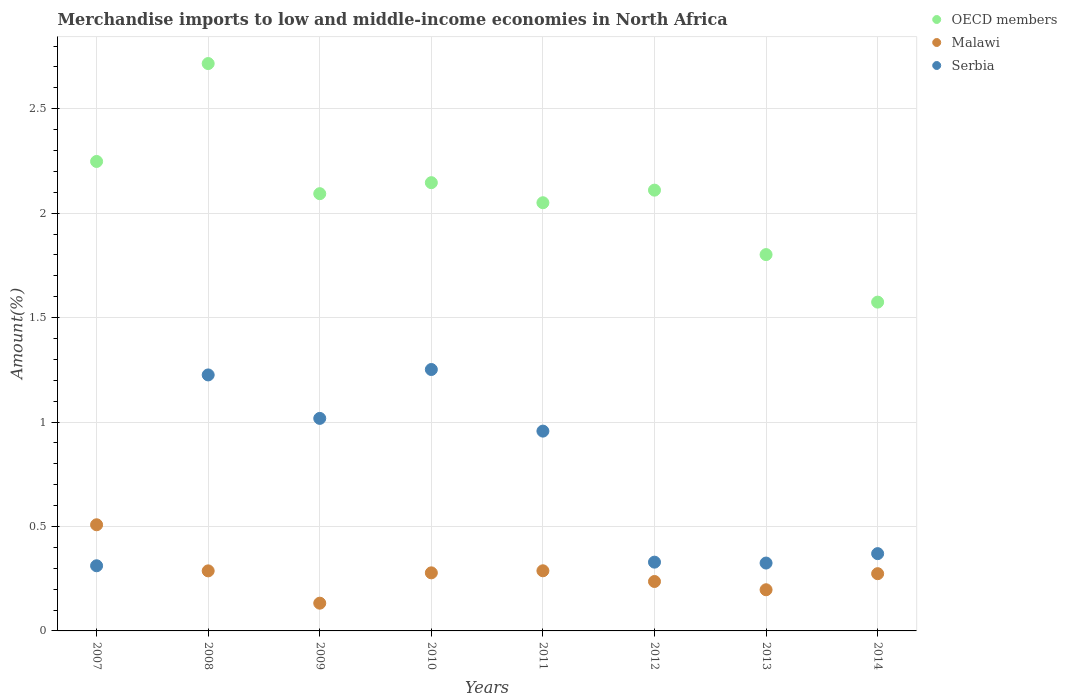How many different coloured dotlines are there?
Your response must be concise. 3. What is the percentage of amount earned from merchandise imports in Serbia in 2008?
Your response must be concise. 1.23. Across all years, what is the maximum percentage of amount earned from merchandise imports in Malawi?
Give a very brief answer. 0.51. Across all years, what is the minimum percentage of amount earned from merchandise imports in Malawi?
Provide a succinct answer. 0.13. What is the total percentage of amount earned from merchandise imports in Malawi in the graph?
Give a very brief answer. 2.2. What is the difference between the percentage of amount earned from merchandise imports in Malawi in 2011 and that in 2013?
Provide a succinct answer. 0.09. What is the difference between the percentage of amount earned from merchandise imports in OECD members in 2011 and the percentage of amount earned from merchandise imports in Malawi in 2007?
Provide a short and direct response. 1.54. What is the average percentage of amount earned from merchandise imports in Serbia per year?
Ensure brevity in your answer.  0.72. In the year 2012, what is the difference between the percentage of amount earned from merchandise imports in OECD members and percentage of amount earned from merchandise imports in Serbia?
Provide a succinct answer. 1.78. What is the ratio of the percentage of amount earned from merchandise imports in Malawi in 2009 to that in 2014?
Make the answer very short. 0.48. What is the difference between the highest and the second highest percentage of amount earned from merchandise imports in Malawi?
Give a very brief answer. 0.22. What is the difference between the highest and the lowest percentage of amount earned from merchandise imports in Malawi?
Give a very brief answer. 0.38. In how many years, is the percentage of amount earned from merchandise imports in Malawi greater than the average percentage of amount earned from merchandise imports in Malawi taken over all years?
Provide a short and direct response. 4. Does the percentage of amount earned from merchandise imports in OECD members monotonically increase over the years?
Ensure brevity in your answer.  No. How many dotlines are there?
Keep it short and to the point. 3. How many years are there in the graph?
Offer a very short reply. 8. What is the difference between two consecutive major ticks on the Y-axis?
Keep it short and to the point. 0.5. Are the values on the major ticks of Y-axis written in scientific E-notation?
Offer a very short reply. No. Does the graph contain any zero values?
Provide a short and direct response. No. Does the graph contain grids?
Provide a short and direct response. Yes. Where does the legend appear in the graph?
Provide a short and direct response. Top right. How many legend labels are there?
Your response must be concise. 3. What is the title of the graph?
Provide a succinct answer. Merchandise imports to low and middle-income economies in North Africa. Does "St. Martin (French part)" appear as one of the legend labels in the graph?
Keep it short and to the point. No. What is the label or title of the X-axis?
Provide a succinct answer. Years. What is the label or title of the Y-axis?
Your answer should be compact. Amount(%). What is the Amount(%) in OECD members in 2007?
Offer a very short reply. 2.25. What is the Amount(%) in Malawi in 2007?
Provide a short and direct response. 0.51. What is the Amount(%) in Serbia in 2007?
Your response must be concise. 0.31. What is the Amount(%) of OECD members in 2008?
Provide a short and direct response. 2.72. What is the Amount(%) in Malawi in 2008?
Your answer should be compact. 0.29. What is the Amount(%) of Serbia in 2008?
Your answer should be compact. 1.23. What is the Amount(%) of OECD members in 2009?
Your answer should be very brief. 2.09. What is the Amount(%) in Malawi in 2009?
Offer a terse response. 0.13. What is the Amount(%) of Serbia in 2009?
Your answer should be compact. 1.02. What is the Amount(%) in OECD members in 2010?
Your answer should be very brief. 2.15. What is the Amount(%) in Malawi in 2010?
Provide a succinct answer. 0.28. What is the Amount(%) of Serbia in 2010?
Provide a short and direct response. 1.25. What is the Amount(%) of OECD members in 2011?
Your answer should be compact. 2.05. What is the Amount(%) in Malawi in 2011?
Your answer should be compact. 0.29. What is the Amount(%) of Serbia in 2011?
Offer a very short reply. 0.96. What is the Amount(%) of OECD members in 2012?
Make the answer very short. 2.11. What is the Amount(%) in Malawi in 2012?
Keep it short and to the point. 0.24. What is the Amount(%) in Serbia in 2012?
Make the answer very short. 0.33. What is the Amount(%) of OECD members in 2013?
Make the answer very short. 1.8. What is the Amount(%) in Malawi in 2013?
Make the answer very short. 0.2. What is the Amount(%) of Serbia in 2013?
Your answer should be very brief. 0.32. What is the Amount(%) of OECD members in 2014?
Your answer should be very brief. 1.57. What is the Amount(%) in Malawi in 2014?
Offer a terse response. 0.27. What is the Amount(%) of Serbia in 2014?
Provide a succinct answer. 0.37. Across all years, what is the maximum Amount(%) in OECD members?
Your answer should be very brief. 2.72. Across all years, what is the maximum Amount(%) in Malawi?
Your response must be concise. 0.51. Across all years, what is the maximum Amount(%) in Serbia?
Your response must be concise. 1.25. Across all years, what is the minimum Amount(%) of OECD members?
Make the answer very short. 1.57. Across all years, what is the minimum Amount(%) of Malawi?
Your answer should be compact. 0.13. Across all years, what is the minimum Amount(%) in Serbia?
Make the answer very short. 0.31. What is the total Amount(%) in OECD members in the graph?
Give a very brief answer. 16.74. What is the total Amount(%) in Malawi in the graph?
Keep it short and to the point. 2.2. What is the total Amount(%) of Serbia in the graph?
Provide a succinct answer. 5.79. What is the difference between the Amount(%) of OECD members in 2007 and that in 2008?
Offer a very short reply. -0.47. What is the difference between the Amount(%) of Malawi in 2007 and that in 2008?
Offer a very short reply. 0.22. What is the difference between the Amount(%) of Serbia in 2007 and that in 2008?
Your answer should be compact. -0.91. What is the difference between the Amount(%) of OECD members in 2007 and that in 2009?
Your answer should be compact. 0.15. What is the difference between the Amount(%) of Malawi in 2007 and that in 2009?
Your answer should be very brief. 0.38. What is the difference between the Amount(%) of Serbia in 2007 and that in 2009?
Provide a short and direct response. -0.71. What is the difference between the Amount(%) of OECD members in 2007 and that in 2010?
Ensure brevity in your answer.  0.1. What is the difference between the Amount(%) in Malawi in 2007 and that in 2010?
Provide a short and direct response. 0.23. What is the difference between the Amount(%) in Serbia in 2007 and that in 2010?
Offer a terse response. -0.94. What is the difference between the Amount(%) in OECD members in 2007 and that in 2011?
Your response must be concise. 0.2. What is the difference between the Amount(%) of Malawi in 2007 and that in 2011?
Your answer should be compact. 0.22. What is the difference between the Amount(%) of Serbia in 2007 and that in 2011?
Make the answer very short. -0.64. What is the difference between the Amount(%) of OECD members in 2007 and that in 2012?
Your response must be concise. 0.14. What is the difference between the Amount(%) in Malawi in 2007 and that in 2012?
Offer a very short reply. 0.27. What is the difference between the Amount(%) in Serbia in 2007 and that in 2012?
Offer a very short reply. -0.02. What is the difference between the Amount(%) of OECD members in 2007 and that in 2013?
Ensure brevity in your answer.  0.45. What is the difference between the Amount(%) in Malawi in 2007 and that in 2013?
Ensure brevity in your answer.  0.31. What is the difference between the Amount(%) of Serbia in 2007 and that in 2013?
Offer a terse response. -0.01. What is the difference between the Amount(%) in OECD members in 2007 and that in 2014?
Keep it short and to the point. 0.67. What is the difference between the Amount(%) of Malawi in 2007 and that in 2014?
Ensure brevity in your answer.  0.23. What is the difference between the Amount(%) in Serbia in 2007 and that in 2014?
Your answer should be very brief. -0.06. What is the difference between the Amount(%) of OECD members in 2008 and that in 2009?
Provide a succinct answer. 0.62. What is the difference between the Amount(%) of Malawi in 2008 and that in 2009?
Offer a very short reply. 0.15. What is the difference between the Amount(%) in Serbia in 2008 and that in 2009?
Ensure brevity in your answer.  0.21. What is the difference between the Amount(%) in OECD members in 2008 and that in 2010?
Keep it short and to the point. 0.57. What is the difference between the Amount(%) in Malawi in 2008 and that in 2010?
Keep it short and to the point. 0.01. What is the difference between the Amount(%) of Serbia in 2008 and that in 2010?
Provide a short and direct response. -0.03. What is the difference between the Amount(%) of OECD members in 2008 and that in 2011?
Your answer should be very brief. 0.67. What is the difference between the Amount(%) of Malawi in 2008 and that in 2011?
Provide a succinct answer. -0. What is the difference between the Amount(%) in Serbia in 2008 and that in 2011?
Your response must be concise. 0.27. What is the difference between the Amount(%) of OECD members in 2008 and that in 2012?
Keep it short and to the point. 0.61. What is the difference between the Amount(%) in Malawi in 2008 and that in 2012?
Make the answer very short. 0.05. What is the difference between the Amount(%) of Serbia in 2008 and that in 2012?
Offer a terse response. 0.9. What is the difference between the Amount(%) of OECD members in 2008 and that in 2013?
Your answer should be compact. 0.91. What is the difference between the Amount(%) of Malawi in 2008 and that in 2013?
Ensure brevity in your answer.  0.09. What is the difference between the Amount(%) of Serbia in 2008 and that in 2013?
Give a very brief answer. 0.9. What is the difference between the Amount(%) of OECD members in 2008 and that in 2014?
Ensure brevity in your answer.  1.14. What is the difference between the Amount(%) in Malawi in 2008 and that in 2014?
Ensure brevity in your answer.  0.01. What is the difference between the Amount(%) of Serbia in 2008 and that in 2014?
Give a very brief answer. 0.86. What is the difference between the Amount(%) in OECD members in 2009 and that in 2010?
Your response must be concise. -0.05. What is the difference between the Amount(%) of Malawi in 2009 and that in 2010?
Your answer should be very brief. -0.15. What is the difference between the Amount(%) of Serbia in 2009 and that in 2010?
Provide a short and direct response. -0.23. What is the difference between the Amount(%) of OECD members in 2009 and that in 2011?
Make the answer very short. 0.04. What is the difference between the Amount(%) in Malawi in 2009 and that in 2011?
Give a very brief answer. -0.16. What is the difference between the Amount(%) in Serbia in 2009 and that in 2011?
Offer a very short reply. 0.06. What is the difference between the Amount(%) of OECD members in 2009 and that in 2012?
Provide a succinct answer. -0.02. What is the difference between the Amount(%) of Malawi in 2009 and that in 2012?
Ensure brevity in your answer.  -0.1. What is the difference between the Amount(%) of Serbia in 2009 and that in 2012?
Your answer should be compact. 0.69. What is the difference between the Amount(%) of OECD members in 2009 and that in 2013?
Offer a terse response. 0.29. What is the difference between the Amount(%) of Malawi in 2009 and that in 2013?
Ensure brevity in your answer.  -0.06. What is the difference between the Amount(%) of Serbia in 2009 and that in 2013?
Provide a succinct answer. 0.69. What is the difference between the Amount(%) of OECD members in 2009 and that in 2014?
Ensure brevity in your answer.  0.52. What is the difference between the Amount(%) of Malawi in 2009 and that in 2014?
Make the answer very short. -0.14. What is the difference between the Amount(%) of Serbia in 2009 and that in 2014?
Keep it short and to the point. 0.65. What is the difference between the Amount(%) in OECD members in 2010 and that in 2011?
Provide a short and direct response. 0.1. What is the difference between the Amount(%) in Malawi in 2010 and that in 2011?
Provide a succinct answer. -0.01. What is the difference between the Amount(%) in Serbia in 2010 and that in 2011?
Offer a terse response. 0.29. What is the difference between the Amount(%) of OECD members in 2010 and that in 2012?
Make the answer very short. 0.04. What is the difference between the Amount(%) in Malawi in 2010 and that in 2012?
Provide a succinct answer. 0.04. What is the difference between the Amount(%) in Serbia in 2010 and that in 2012?
Offer a very short reply. 0.92. What is the difference between the Amount(%) in OECD members in 2010 and that in 2013?
Provide a succinct answer. 0.34. What is the difference between the Amount(%) in Malawi in 2010 and that in 2013?
Keep it short and to the point. 0.08. What is the difference between the Amount(%) in Serbia in 2010 and that in 2013?
Your answer should be compact. 0.93. What is the difference between the Amount(%) of OECD members in 2010 and that in 2014?
Keep it short and to the point. 0.57. What is the difference between the Amount(%) in Malawi in 2010 and that in 2014?
Keep it short and to the point. 0. What is the difference between the Amount(%) of Serbia in 2010 and that in 2014?
Your response must be concise. 0.88. What is the difference between the Amount(%) in OECD members in 2011 and that in 2012?
Your response must be concise. -0.06. What is the difference between the Amount(%) in Malawi in 2011 and that in 2012?
Your answer should be compact. 0.05. What is the difference between the Amount(%) of Serbia in 2011 and that in 2012?
Ensure brevity in your answer.  0.63. What is the difference between the Amount(%) in OECD members in 2011 and that in 2013?
Offer a very short reply. 0.25. What is the difference between the Amount(%) of Malawi in 2011 and that in 2013?
Your answer should be compact. 0.09. What is the difference between the Amount(%) in Serbia in 2011 and that in 2013?
Offer a terse response. 0.63. What is the difference between the Amount(%) of OECD members in 2011 and that in 2014?
Provide a succinct answer. 0.48. What is the difference between the Amount(%) in Malawi in 2011 and that in 2014?
Keep it short and to the point. 0.01. What is the difference between the Amount(%) of Serbia in 2011 and that in 2014?
Offer a very short reply. 0.59. What is the difference between the Amount(%) in OECD members in 2012 and that in 2013?
Provide a succinct answer. 0.31. What is the difference between the Amount(%) in Malawi in 2012 and that in 2013?
Offer a very short reply. 0.04. What is the difference between the Amount(%) of Serbia in 2012 and that in 2013?
Your answer should be very brief. 0. What is the difference between the Amount(%) in OECD members in 2012 and that in 2014?
Provide a short and direct response. 0.54. What is the difference between the Amount(%) of Malawi in 2012 and that in 2014?
Your response must be concise. -0.04. What is the difference between the Amount(%) in Serbia in 2012 and that in 2014?
Give a very brief answer. -0.04. What is the difference between the Amount(%) in OECD members in 2013 and that in 2014?
Give a very brief answer. 0.23. What is the difference between the Amount(%) of Malawi in 2013 and that in 2014?
Your response must be concise. -0.08. What is the difference between the Amount(%) of Serbia in 2013 and that in 2014?
Provide a succinct answer. -0.05. What is the difference between the Amount(%) in OECD members in 2007 and the Amount(%) in Malawi in 2008?
Keep it short and to the point. 1.96. What is the difference between the Amount(%) of OECD members in 2007 and the Amount(%) of Serbia in 2008?
Provide a succinct answer. 1.02. What is the difference between the Amount(%) in Malawi in 2007 and the Amount(%) in Serbia in 2008?
Keep it short and to the point. -0.72. What is the difference between the Amount(%) of OECD members in 2007 and the Amount(%) of Malawi in 2009?
Your response must be concise. 2.11. What is the difference between the Amount(%) in OECD members in 2007 and the Amount(%) in Serbia in 2009?
Ensure brevity in your answer.  1.23. What is the difference between the Amount(%) of Malawi in 2007 and the Amount(%) of Serbia in 2009?
Give a very brief answer. -0.51. What is the difference between the Amount(%) in OECD members in 2007 and the Amount(%) in Malawi in 2010?
Offer a terse response. 1.97. What is the difference between the Amount(%) of Malawi in 2007 and the Amount(%) of Serbia in 2010?
Ensure brevity in your answer.  -0.74. What is the difference between the Amount(%) in OECD members in 2007 and the Amount(%) in Malawi in 2011?
Provide a succinct answer. 1.96. What is the difference between the Amount(%) in OECD members in 2007 and the Amount(%) in Serbia in 2011?
Provide a succinct answer. 1.29. What is the difference between the Amount(%) in Malawi in 2007 and the Amount(%) in Serbia in 2011?
Your answer should be compact. -0.45. What is the difference between the Amount(%) in OECD members in 2007 and the Amount(%) in Malawi in 2012?
Ensure brevity in your answer.  2.01. What is the difference between the Amount(%) of OECD members in 2007 and the Amount(%) of Serbia in 2012?
Provide a short and direct response. 1.92. What is the difference between the Amount(%) in Malawi in 2007 and the Amount(%) in Serbia in 2012?
Give a very brief answer. 0.18. What is the difference between the Amount(%) of OECD members in 2007 and the Amount(%) of Malawi in 2013?
Your answer should be very brief. 2.05. What is the difference between the Amount(%) of OECD members in 2007 and the Amount(%) of Serbia in 2013?
Offer a terse response. 1.92. What is the difference between the Amount(%) in Malawi in 2007 and the Amount(%) in Serbia in 2013?
Keep it short and to the point. 0.18. What is the difference between the Amount(%) in OECD members in 2007 and the Amount(%) in Malawi in 2014?
Offer a very short reply. 1.97. What is the difference between the Amount(%) of OECD members in 2007 and the Amount(%) of Serbia in 2014?
Your response must be concise. 1.88. What is the difference between the Amount(%) of Malawi in 2007 and the Amount(%) of Serbia in 2014?
Give a very brief answer. 0.14. What is the difference between the Amount(%) in OECD members in 2008 and the Amount(%) in Malawi in 2009?
Keep it short and to the point. 2.58. What is the difference between the Amount(%) in OECD members in 2008 and the Amount(%) in Serbia in 2009?
Ensure brevity in your answer.  1.7. What is the difference between the Amount(%) in Malawi in 2008 and the Amount(%) in Serbia in 2009?
Your response must be concise. -0.73. What is the difference between the Amount(%) in OECD members in 2008 and the Amount(%) in Malawi in 2010?
Ensure brevity in your answer.  2.44. What is the difference between the Amount(%) in OECD members in 2008 and the Amount(%) in Serbia in 2010?
Give a very brief answer. 1.46. What is the difference between the Amount(%) of Malawi in 2008 and the Amount(%) of Serbia in 2010?
Your response must be concise. -0.96. What is the difference between the Amount(%) in OECD members in 2008 and the Amount(%) in Malawi in 2011?
Provide a short and direct response. 2.43. What is the difference between the Amount(%) of OECD members in 2008 and the Amount(%) of Serbia in 2011?
Provide a short and direct response. 1.76. What is the difference between the Amount(%) of Malawi in 2008 and the Amount(%) of Serbia in 2011?
Offer a terse response. -0.67. What is the difference between the Amount(%) in OECD members in 2008 and the Amount(%) in Malawi in 2012?
Your response must be concise. 2.48. What is the difference between the Amount(%) in OECD members in 2008 and the Amount(%) in Serbia in 2012?
Make the answer very short. 2.39. What is the difference between the Amount(%) in Malawi in 2008 and the Amount(%) in Serbia in 2012?
Make the answer very short. -0.04. What is the difference between the Amount(%) of OECD members in 2008 and the Amount(%) of Malawi in 2013?
Ensure brevity in your answer.  2.52. What is the difference between the Amount(%) in OECD members in 2008 and the Amount(%) in Serbia in 2013?
Ensure brevity in your answer.  2.39. What is the difference between the Amount(%) in Malawi in 2008 and the Amount(%) in Serbia in 2013?
Make the answer very short. -0.04. What is the difference between the Amount(%) of OECD members in 2008 and the Amount(%) of Malawi in 2014?
Ensure brevity in your answer.  2.44. What is the difference between the Amount(%) in OECD members in 2008 and the Amount(%) in Serbia in 2014?
Make the answer very short. 2.35. What is the difference between the Amount(%) of Malawi in 2008 and the Amount(%) of Serbia in 2014?
Your answer should be very brief. -0.08. What is the difference between the Amount(%) of OECD members in 2009 and the Amount(%) of Malawi in 2010?
Your response must be concise. 1.82. What is the difference between the Amount(%) of OECD members in 2009 and the Amount(%) of Serbia in 2010?
Your answer should be very brief. 0.84. What is the difference between the Amount(%) of Malawi in 2009 and the Amount(%) of Serbia in 2010?
Offer a terse response. -1.12. What is the difference between the Amount(%) in OECD members in 2009 and the Amount(%) in Malawi in 2011?
Provide a short and direct response. 1.81. What is the difference between the Amount(%) of OECD members in 2009 and the Amount(%) of Serbia in 2011?
Your answer should be compact. 1.14. What is the difference between the Amount(%) of Malawi in 2009 and the Amount(%) of Serbia in 2011?
Make the answer very short. -0.82. What is the difference between the Amount(%) in OECD members in 2009 and the Amount(%) in Malawi in 2012?
Your response must be concise. 1.86. What is the difference between the Amount(%) of OECD members in 2009 and the Amount(%) of Serbia in 2012?
Provide a short and direct response. 1.76. What is the difference between the Amount(%) of Malawi in 2009 and the Amount(%) of Serbia in 2012?
Your answer should be very brief. -0.2. What is the difference between the Amount(%) in OECD members in 2009 and the Amount(%) in Malawi in 2013?
Give a very brief answer. 1.9. What is the difference between the Amount(%) in OECD members in 2009 and the Amount(%) in Serbia in 2013?
Make the answer very short. 1.77. What is the difference between the Amount(%) of Malawi in 2009 and the Amount(%) of Serbia in 2013?
Ensure brevity in your answer.  -0.19. What is the difference between the Amount(%) in OECD members in 2009 and the Amount(%) in Malawi in 2014?
Your answer should be compact. 1.82. What is the difference between the Amount(%) in OECD members in 2009 and the Amount(%) in Serbia in 2014?
Make the answer very short. 1.72. What is the difference between the Amount(%) of Malawi in 2009 and the Amount(%) of Serbia in 2014?
Give a very brief answer. -0.24. What is the difference between the Amount(%) of OECD members in 2010 and the Amount(%) of Malawi in 2011?
Offer a very short reply. 1.86. What is the difference between the Amount(%) in OECD members in 2010 and the Amount(%) in Serbia in 2011?
Offer a very short reply. 1.19. What is the difference between the Amount(%) in Malawi in 2010 and the Amount(%) in Serbia in 2011?
Offer a very short reply. -0.68. What is the difference between the Amount(%) in OECD members in 2010 and the Amount(%) in Malawi in 2012?
Provide a short and direct response. 1.91. What is the difference between the Amount(%) in OECD members in 2010 and the Amount(%) in Serbia in 2012?
Offer a very short reply. 1.82. What is the difference between the Amount(%) of Malawi in 2010 and the Amount(%) of Serbia in 2012?
Your answer should be very brief. -0.05. What is the difference between the Amount(%) of OECD members in 2010 and the Amount(%) of Malawi in 2013?
Ensure brevity in your answer.  1.95. What is the difference between the Amount(%) in OECD members in 2010 and the Amount(%) in Serbia in 2013?
Offer a very short reply. 1.82. What is the difference between the Amount(%) of Malawi in 2010 and the Amount(%) of Serbia in 2013?
Ensure brevity in your answer.  -0.05. What is the difference between the Amount(%) in OECD members in 2010 and the Amount(%) in Malawi in 2014?
Your answer should be compact. 1.87. What is the difference between the Amount(%) in OECD members in 2010 and the Amount(%) in Serbia in 2014?
Give a very brief answer. 1.78. What is the difference between the Amount(%) of Malawi in 2010 and the Amount(%) of Serbia in 2014?
Ensure brevity in your answer.  -0.09. What is the difference between the Amount(%) in OECD members in 2011 and the Amount(%) in Malawi in 2012?
Your response must be concise. 1.81. What is the difference between the Amount(%) of OECD members in 2011 and the Amount(%) of Serbia in 2012?
Offer a terse response. 1.72. What is the difference between the Amount(%) in Malawi in 2011 and the Amount(%) in Serbia in 2012?
Make the answer very short. -0.04. What is the difference between the Amount(%) in OECD members in 2011 and the Amount(%) in Malawi in 2013?
Your answer should be compact. 1.85. What is the difference between the Amount(%) in OECD members in 2011 and the Amount(%) in Serbia in 2013?
Offer a terse response. 1.73. What is the difference between the Amount(%) of Malawi in 2011 and the Amount(%) of Serbia in 2013?
Ensure brevity in your answer.  -0.04. What is the difference between the Amount(%) in OECD members in 2011 and the Amount(%) in Malawi in 2014?
Offer a terse response. 1.78. What is the difference between the Amount(%) of OECD members in 2011 and the Amount(%) of Serbia in 2014?
Your answer should be very brief. 1.68. What is the difference between the Amount(%) in Malawi in 2011 and the Amount(%) in Serbia in 2014?
Your answer should be very brief. -0.08. What is the difference between the Amount(%) in OECD members in 2012 and the Amount(%) in Malawi in 2013?
Provide a short and direct response. 1.91. What is the difference between the Amount(%) in OECD members in 2012 and the Amount(%) in Serbia in 2013?
Ensure brevity in your answer.  1.79. What is the difference between the Amount(%) in Malawi in 2012 and the Amount(%) in Serbia in 2013?
Your answer should be compact. -0.09. What is the difference between the Amount(%) in OECD members in 2012 and the Amount(%) in Malawi in 2014?
Your answer should be compact. 1.84. What is the difference between the Amount(%) of OECD members in 2012 and the Amount(%) of Serbia in 2014?
Give a very brief answer. 1.74. What is the difference between the Amount(%) of Malawi in 2012 and the Amount(%) of Serbia in 2014?
Give a very brief answer. -0.13. What is the difference between the Amount(%) of OECD members in 2013 and the Amount(%) of Malawi in 2014?
Ensure brevity in your answer.  1.53. What is the difference between the Amount(%) of OECD members in 2013 and the Amount(%) of Serbia in 2014?
Offer a very short reply. 1.43. What is the difference between the Amount(%) of Malawi in 2013 and the Amount(%) of Serbia in 2014?
Your answer should be very brief. -0.17. What is the average Amount(%) of OECD members per year?
Your answer should be very brief. 2.09. What is the average Amount(%) of Malawi per year?
Your answer should be compact. 0.28. What is the average Amount(%) in Serbia per year?
Keep it short and to the point. 0.72. In the year 2007, what is the difference between the Amount(%) of OECD members and Amount(%) of Malawi?
Your answer should be compact. 1.74. In the year 2007, what is the difference between the Amount(%) of OECD members and Amount(%) of Serbia?
Ensure brevity in your answer.  1.94. In the year 2007, what is the difference between the Amount(%) in Malawi and Amount(%) in Serbia?
Keep it short and to the point. 0.2. In the year 2008, what is the difference between the Amount(%) in OECD members and Amount(%) in Malawi?
Ensure brevity in your answer.  2.43. In the year 2008, what is the difference between the Amount(%) in OECD members and Amount(%) in Serbia?
Provide a short and direct response. 1.49. In the year 2008, what is the difference between the Amount(%) in Malawi and Amount(%) in Serbia?
Your answer should be compact. -0.94. In the year 2009, what is the difference between the Amount(%) in OECD members and Amount(%) in Malawi?
Give a very brief answer. 1.96. In the year 2009, what is the difference between the Amount(%) in OECD members and Amount(%) in Serbia?
Ensure brevity in your answer.  1.08. In the year 2009, what is the difference between the Amount(%) of Malawi and Amount(%) of Serbia?
Provide a succinct answer. -0.88. In the year 2010, what is the difference between the Amount(%) in OECD members and Amount(%) in Malawi?
Offer a very short reply. 1.87. In the year 2010, what is the difference between the Amount(%) of OECD members and Amount(%) of Serbia?
Provide a short and direct response. 0.89. In the year 2010, what is the difference between the Amount(%) of Malawi and Amount(%) of Serbia?
Your answer should be very brief. -0.97. In the year 2011, what is the difference between the Amount(%) of OECD members and Amount(%) of Malawi?
Provide a succinct answer. 1.76. In the year 2011, what is the difference between the Amount(%) in OECD members and Amount(%) in Serbia?
Offer a terse response. 1.09. In the year 2011, what is the difference between the Amount(%) in Malawi and Amount(%) in Serbia?
Ensure brevity in your answer.  -0.67. In the year 2012, what is the difference between the Amount(%) of OECD members and Amount(%) of Malawi?
Offer a terse response. 1.87. In the year 2012, what is the difference between the Amount(%) of OECD members and Amount(%) of Serbia?
Give a very brief answer. 1.78. In the year 2012, what is the difference between the Amount(%) in Malawi and Amount(%) in Serbia?
Offer a very short reply. -0.09. In the year 2013, what is the difference between the Amount(%) of OECD members and Amount(%) of Malawi?
Ensure brevity in your answer.  1.6. In the year 2013, what is the difference between the Amount(%) in OECD members and Amount(%) in Serbia?
Your response must be concise. 1.48. In the year 2013, what is the difference between the Amount(%) of Malawi and Amount(%) of Serbia?
Ensure brevity in your answer.  -0.13. In the year 2014, what is the difference between the Amount(%) of OECD members and Amount(%) of Malawi?
Make the answer very short. 1.3. In the year 2014, what is the difference between the Amount(%) in OECD members and Amount(%) in Serbia?
Keep it short and to the point. 1.2. In the year 2014, what is the difference between the Amount(%) in Malawi and Amount(%) in Serbia?
Offer a very short reply. -0.1. What is the ratio of the Amount(%) of OECD members in 2007 to that in 2008?
Provide a short and direct response. 0.83. What is the ratio of the Amount(%) of Malawi in 2007 to that in 2008?
Keep it short and to the point. 1.77. What is the ratio of the Amount(%) in Serbia in 2007 to that in 2008?
Offer a very short reply. 0.25. What is the ratio of the Amount(%) of OECD members in 2007 to that in 2009?
Provide a short and direct response. 1.07. What is the ratio of the Amount(%) of Malawi in 2007 to that in 2009?
Offer a very short reply. 3.83. What is the ratio of the Amount(%) in Serbia in 2007 to that in 2009?
Provide a short and direct response. 0.31. What is the ratio of the Amount(%) of OECD members in 2007 to that in 2010?
Make the answer very short. 1.05. What is the ratio of the Amount(%) of Malawi in 2007 to that in 2010?
Provide a succinct answer. 1.83. What is the ratio of the Amount(%) of Serbia in 2007 to that in 2010?
Your answer should be very brief. 0.25. What is the ratio of the Amount(%) of OECD members in 2007 to that in 2011?
Keep it short and to the point. 1.1. What is the ratio of the Amount(%) in Malawi in 2007 to that in 2011?
Ensure brevity in your answer.  1.77. What is the ratio of the Amount(%) in Serbia in 2007 to that in 2011?
Provide a short and direct response. 0.33. What is the ratio of the Amount(%) in OECD members in 2007 to that in 2012?
Keep it short and to the point. 1.07. What is the ratio of the Amount(%) of Malawi in 2007 to that in 2012?
Provide a succinct answer. 2.15. What is the ratio of the Amount(%) of Serbia in 2007 to that in 2012?
Offer a terse response. 0.95. What is the ratio of the Amount(%) of OECD members in 2007 to that in 2013?
Offer a very short reply. 1.25. What is the ratio of the Amount(%) of Malawi in 2007 to that in 2013?
Provide a short and direct response. 2.58. What is the ratio of the Amount(%) in Serbia in 2007 to that in 2013?
Offer a terse response. 0.96. What is the ratio of the Amount(%) of OECD members in 2007 to that in 2014?
Provide a short and direct response. 1.43. What is the ratio of the Amount(%) in Malawi in 2007 to that in 2014?
Your answer should be compact. 1.85. What is the ratio of the Amount(%) in Serbia in 2007 to that in 2014?
Offer a very short reply. 0.84. What is the ratio of the Amount(%) of OECD members in 2008 to that in 2009?
Your response must be concise. 1.3. What is the ratio of the Amount(%) of Malawi in 2008 to that in 2009?
Provide a succinct answer. 2.16. What is the ratio of the Amount(%) of Serbia in 2008 to that in 2009?
Your response must be concise. 1.2. What is the ratio of the Amount(%) in OECD members in 2008 to that in 2010?
Provide a succinct answer. 1.27. What is the ratio of the Amount(%) of Malawi in 2008 to that in 2010?
Provide a short and direct response. 1.03. What is the ratio of the Amount(%) in Serbia in 2008 to that in 2010?
Ensure brevity in your answer.  0.98. What is the ratio of the Amount(%) in OECD members in 2008 to that in 2011?
Offer a very short reply. 1.32. What is the ratio of the Amount(%) in Serbia in 2008 to that in 2011?
Provide a short and direct response. 1.28. What is the ratio of the Amount(%) in OECD members in 2008 to that in 2012?
Make the answer very short. 1.29. What is the ratio of the Amount(%) of Malawi in 2008 to that in 2012?
Make the answer very short. 1.21. What is the ratio of the Amount(%) of Serbia in 2008 to that in 2012?
Offer a very short reply. 3.72. What is the ratio of the Amount(%) in OECD members in 2008 to that in 2013?
Provide a short and direct response. 1.51. What is the ratio of the Amount(%) in Malawi in 2008 to that in 2013?
Your answer should be very brief. 1.46. What is the ratio of the Amount(%) in Serbia in 2008 to that in 2013?
Your answer should be compact. 3.77. What is the ratio of the Amount(%) of OECD members in 2008 to that in 2014?
Your answer should be very brief. 1.73. What is the ratio of the Amount(%) of Malawi in 2008 to that in 2014?
Your answer should be very brief. 1.05. What is the ratio of the Amount(%) of Serbia in 2008 to that in 2014?
Offer a terse response. 3.31. What is the ratio of the Amount(%) of OECD members in 2009 to that in 2010?
Make the answer very short. 0.98. What is the ratio of the Amount(%) of Malawi in 2009 to that in 2010?
Make the answer very short. 0.48. What is the ratio of the Amount(%) in Serbia in 2009 to that in 2010?
Offer a very short reply. 0.81. What is the ratio of the Amount(%) in OECD members in 2009 to that in 2011?
Your response must be concise. 1.02. What is the ratio of the Amount(%) of Malawi in 2009 to that in 2011?
Ensure brevity in your answer.  0.46. What is the ratio of the Amount(%) in Serbia in 2009 to that in 2011?
Make the answer very short. 1.06. What is the ratio of the Amount(%) of OECD members in 2009 to that in 2012?
Give a very brief answer. 0.99. What is the ratio of the Amount(%) of Malawi in 2009 to that in 2012?
Keep it short and to the point. 0.56. What is the ratio of the Amount(%) in Serbia in 2009 to that in 2012?
Your response must be concise. 3.09. What is the ratio of the Amount(%) of OECD members in 2009 to that in 2013?
Provide a short and direct response. 1.16. What is the ratio of the Amount(%) in Malawi in 2009 to that in 2013?
Your answer should be compact. 0.67. What is the ratio of the Amount(%) of Serbia in 2009 to that in 2013?
Ensure brevity in your answer.  3.13. What is the ratio of the Amount(%) in OECD members in 2009 to that in 2014?
Provide a succinct answer. 1.33. What is the ratio of the Amount(%) of Malawi in 2009 to that in 2014?
Offer a very short reply. 0.48. What is the ratio of the Amount(%) of Serbia in 2009 to that in 2014?
Your response must be concise. 2.75. What is the ratio of the Amount(%) of OECD members in 2010 to that in 2011?
Offer a very short reply. 1.05. What is the ratio of the Amount(%) in Malawi in 2010 to that in 2011?
Your answer should be compact. 0.97. What is the ratio of the Amount(%) of Serbia in 2010 to that in 2011?
Your answer should be compact. 1.31. What is the ratio of the Amount(%) of Malawi in 2010 to that in 2012?
Your answer should be very brief. 1.17. What is the ratio of the Amount(%) of Serbia in 2010 to that in 2012?
Your answer should be compact. 3.8. What is the ratio of the Amount(%) in OECD members in 2010 to that in 2013?
Give a very brief answer. 1.19. What is the ratio of the Amount(%) of Malawi in 2010 to that in 2013?
Provide a succinct answer. 1.41. What is the ratio of the Amount(%) in Serbia in 2010 to that in 2013?
Your response must be concise. 3.85. What is the ratio of the Amount(%) of OECD members in 2010 to that in 2014?
Your response must be concise. 1.36. What is the ratio of the Amount(%) in Malawi in 2010 to that in 2014?
Ensure brevity in your answer.  1.01. What is the ratio of the Amount(%) of Serbia in 2010 to that in 2014?
Give a very brief answer. 3.38. What is the ratio of the Amount(%) of OECD members in 2011 to that in 2012?
Make the answer very short. 0.97. What is the ratio of the Amount(%) of Malawi in 2011 to that in 2012?
Your answer should be compact. 1.22. What is the ratio of the Amount(%) of Serbia in 2011 to that in 2012?
Keep it short and to the point. 2.91. What is the ratio of the Amount(%) of OECD members in 2011 to that in 2013?
Provide a short and direct response. 1.14. What is the ratio of the Amount(%) in Malawi in 2011 to that in 2013?
Offer a terse response. 1.46. What is the ratio of the Amount(%) in Serbia in 2011 to that in 2013?
Provide a succinct answer. 2.94. What is the ratio of the Amount(%) of OECD members in 2011 to that in 2014?
Your answer should be very brief. 1.3. What is the ratio of the Amount(%) of Malawi in 2011 to that in 2014?
Offer a very short reply. 1.05. What is the ratio of the Amount(%) in Serbia in 2011 to that in 2014?
Your answer should be very brief. 2.59. What is the ratio of the Amount(%) in OECD members in 2012 to that in 2013?
Your response must be concise. 1.17. What is the ratio of the Amount(%) in Malawi in 2012 to that in 2013?
Offer a very short reply. 1.2. What is the ratio of the Amount(%) in Serbia in 2012 to that in 2013?
Give a very brief answer. 1.01. What is the ratio of the Amount(%) in OECD members in 2012 to that in 2014?
Your response must be concise. 1.34. What is the ratio of the Amount(%) in Malawi in 2012 to that in 2014?
Your answer should be very brief. 0.86. What is the ratio of the Amount(%) of Serbia in 2012 to that in 2014?
Your response must be concise. 0.89. What is the ratio of the Amount(%) of OECD members in 2013 to that in 2014?
Give a very brief answer. 1.14. What is the ratio of the Amount(%) in Malawi in 2013 to that in 2014?
Provide a succinct answer. 0.72. What is the ratio of the Amount(%) in Serbia in 2013 to that in 2014?
Make the answer very short. 0.88. What is the difference between the highest and the second highest Amount(%) in OECD members?
Keep it short and to the point. 0.47. What is the difference between the highest and the second highest Amount(%) in Malawi?
Offer a terse response. 0.22. What is the difference between the highest and the second highest Amount(%) in Serbia?
Your answer should be very brief. 0.03. What is the difference between the highest and the lowest Amount(%) in OECD members?
Your answer should be very brief. 1.14. What is the difference between the highest and the lowest Amount(%) of Malawi?
Give a very brief answer. 0.38. What is the difference between the highest and the lowest Amount(%) in Serbia?
Provide a short and direct response. 0.94. 